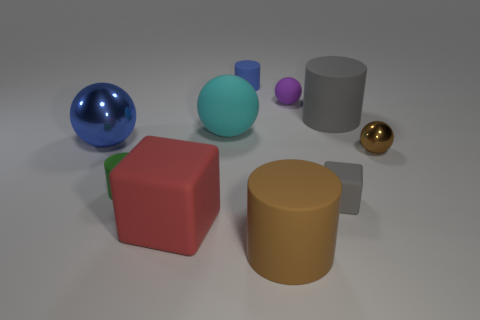Subtract all green cylinders. How many cylinders are left? 3 Subtract all green cylinders. How many cylinders are left? 3 Subtract all cylinders. How many objects are left? 6 Subtract 3 balls. How many balls are left? 1 Subtract all green cubes. Subtract all red spheres. How many cubes are left? 2 Subtract all brown blocks. How many brown cylinders are left? 1 Subtract all rubber balls. Subtract all big purple spheres. How many objects are left? 8 Add 2 small rubber balls. How many small rubber balls are left? 3 Add 10 red rubber cylinders. How many red rubber cylinders exist? 10 Subtract 1 gray blocks. How many objects are left? 9 